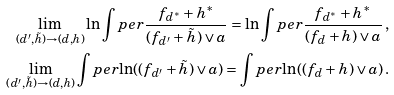Convert formula to latex. <formula><loc_0><loc_0><loc_500><loc_500>\lim _ { ( d ^ { \prime } , \tilde { h } ) \to ( d , h ) } \ln \int p e r { \frac { f _ { d ^ { * } } + h ^ { * } } { ( f _ { d ^ { \prime } } + \tilde { h } ) \vee a } } = \ln \int p e r { \frac { f _ { d ^ { * } } + h ^ { * } } { ( f _ { d } + h ) \vee a } } \, , \\ \lim _ { ( d ^ { \prime } , \tilde { h } ) \to ( d , h ) } \int p e r { \ln ( ( f _ { d ^ { \prime } } + \tilde { h } ) \vee a ) } = \int p e r { \ln ( ( f _ { d } + h ) \vee a ) } \, .</formula> 